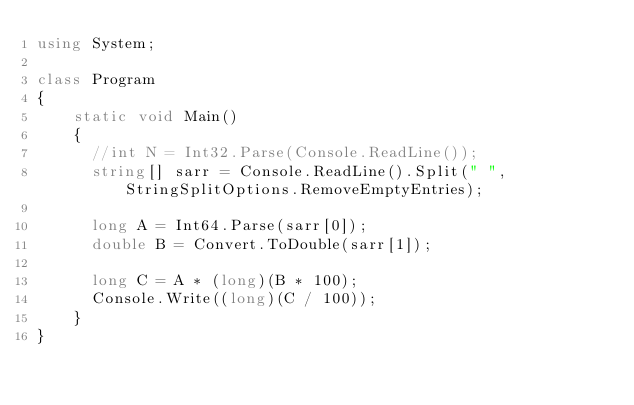<code> <loc_0><loc_0><loc_500><loc_500><_C#_>using System;

class Program
{
    static void Main()
    {
      //int N = Int32.Parse(Console.ReadLine());
      string[] sarr = Console.ReadLine().Split(" ",StringSplitOptions.RemoveEmptyEntries);
      
      long A = Int64.Parse(sarr[0]);
      double B = Convert.ToDouble(sarr[1]);
      
      long C = A * (long)(B * 100);
      Console.Write((long)(C / 100));
    }
}</code> 